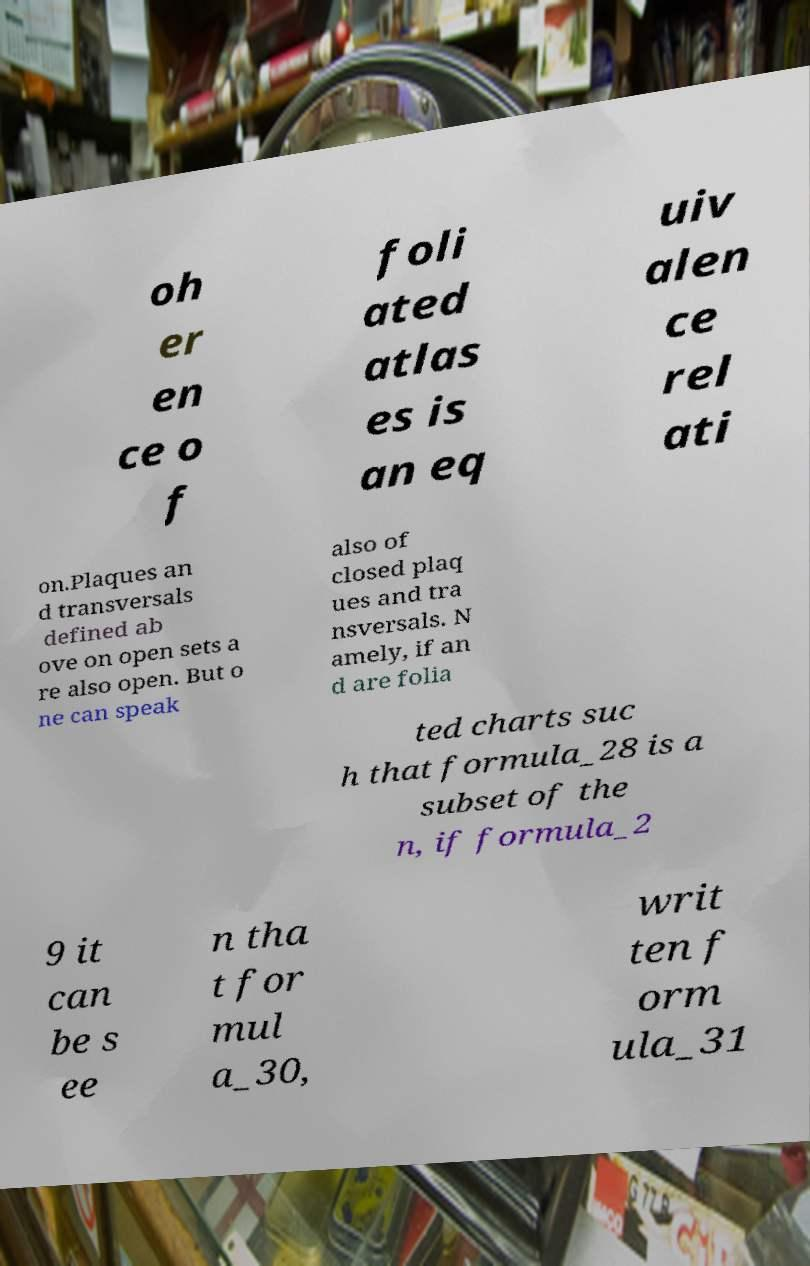Please read and relay the text visible in this image. What does it say? oh er en ce o f foli ated atlas es is an eq uiv alen ce rel ati on.Plaques an d transversals defined ab ove on open sets a re also open. But o ne can speak also of closed plaq ues and tra nsversals. N amely, if an d are folia ted charts suc h that formula_28 is a subset of the n, if formula_2 9 it can be s ee n tha t for mul a_30, writ ten f orm ula_31 